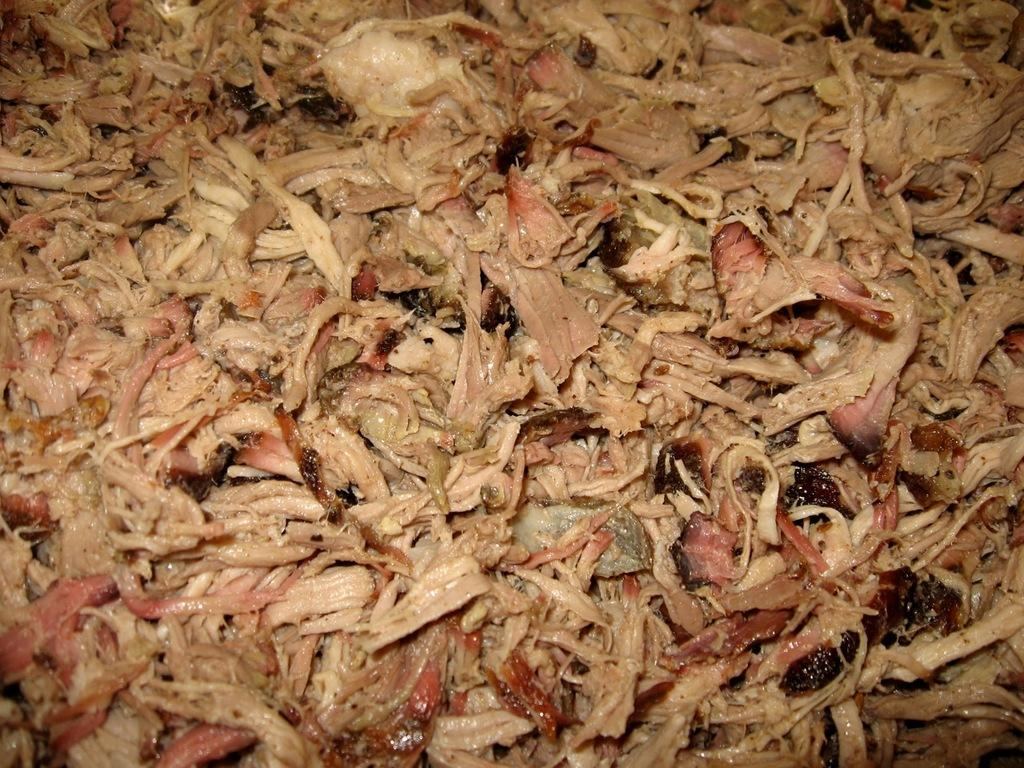What type of food is visible in the image? There is meat in the image. What type of quill is being used to write in the notebook in the image? There is no quill or notebook present in the image; it only features meat. 